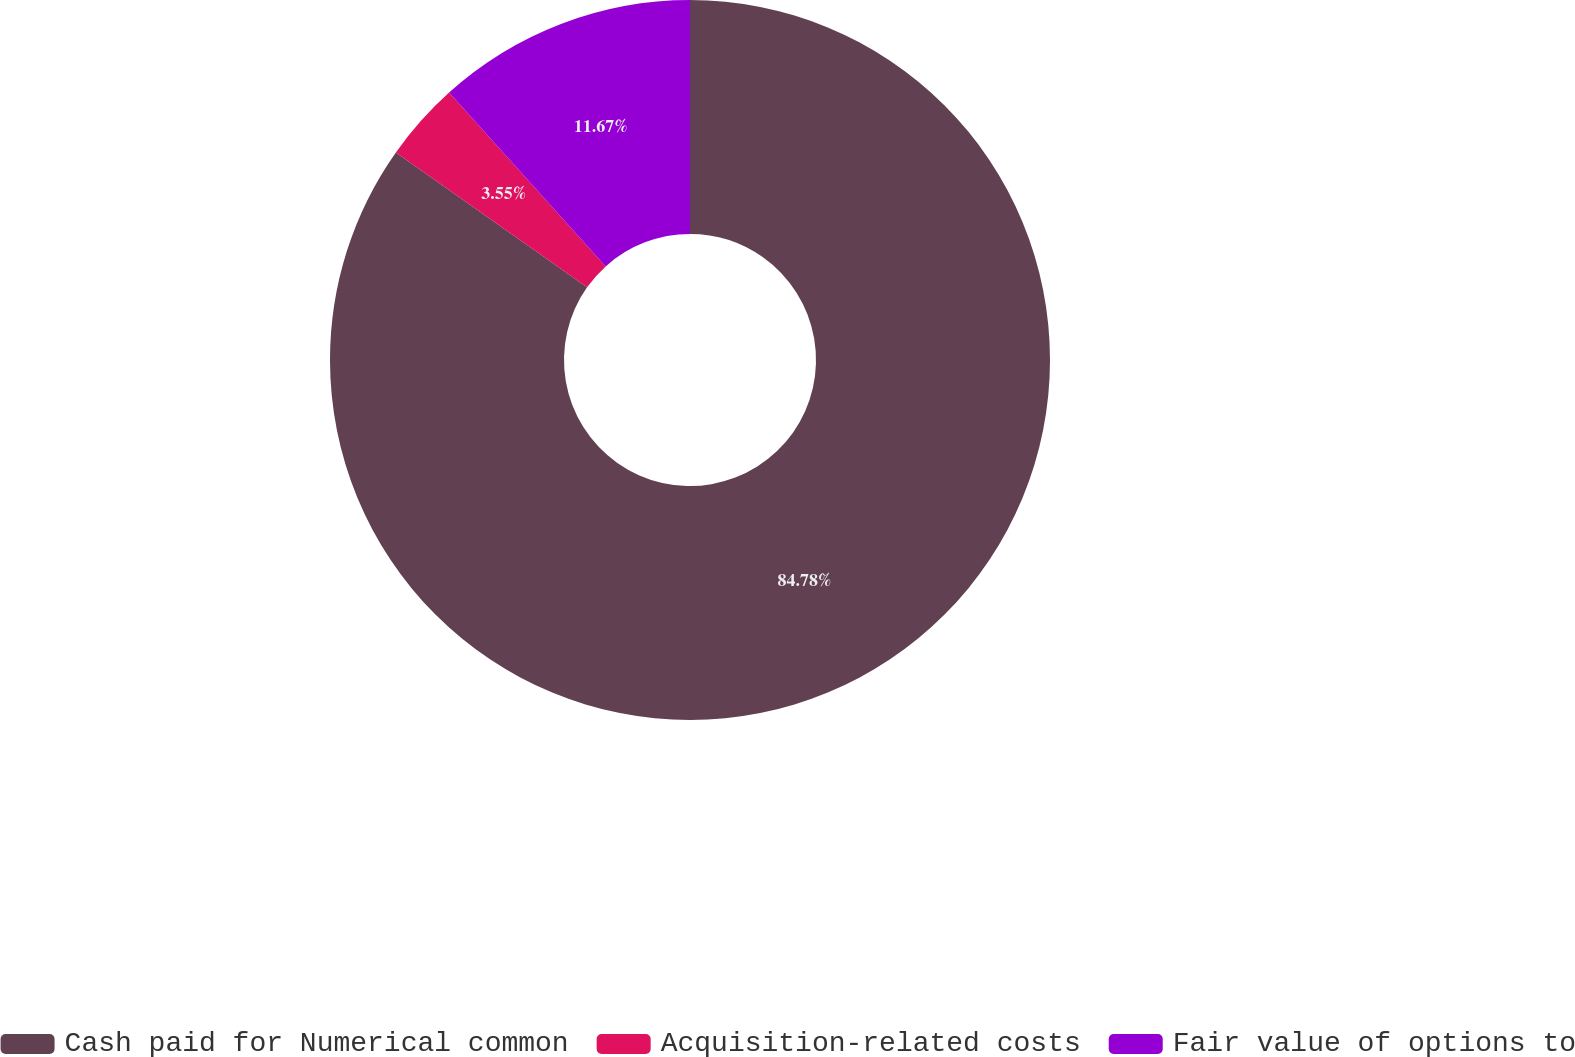<chart> <loc_0><loc_0><loc_500><loc_500><pie_chart><fcel>Cash paid for Numerical common<fcel>Acquisition-related costs<fcel>Fair value of options to<nl><fcel>84.79%<fcel>3.55%<fcel>11.67%<nl></chart> 